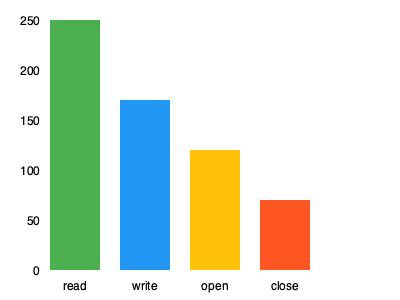Given the bar chart showing system call frequencies in a running Linux process, what is the ratio of read operations to write operations, and what Linux command could you use to generate similar data for analysis? To answer this question, we need to follow these steps:

1. Analyze the bar chart:
   - The chart shows the frequency of four system calls: read, write, open, and close.
   - The y-axis represents the number of calls, while the x-axis shows the different system calls.

2. Determine the frequencies:
   - read: 250 calls
   - write: 170 calls

3. Calculate the ratio of read to write operations:
   $\frac{\text{read}}{\text{write}} = \frac{250}{170} \approx 1.47$

4. Linux command to generate similar data:
   The `strace` command can be used to trace system calls and signals in a running process. To generate data similar to what's shown in the chart, you could use:
   ```
   strace -c -p <PID>
   ```
   Where:
   - `-c` provides a summary count of system calls
   - `-p <PID>` attaches to a running process with the specified Process ID

This command will provide a tabular output of system call frequencies, which could be easily converted into a bar chart for visualization.
Answer: Ratio: 1.47, Command: strace -c -p <PID> 